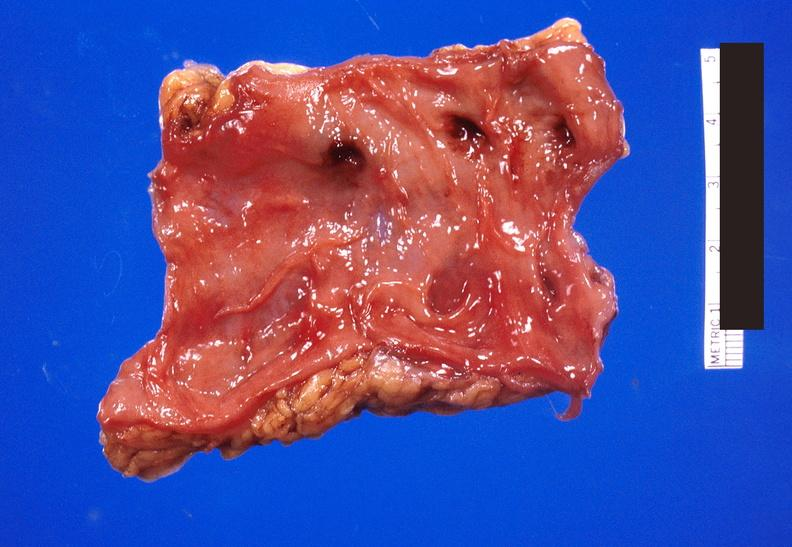what is present?
Answer the question using a single word or phrase. Gastrointestinal 